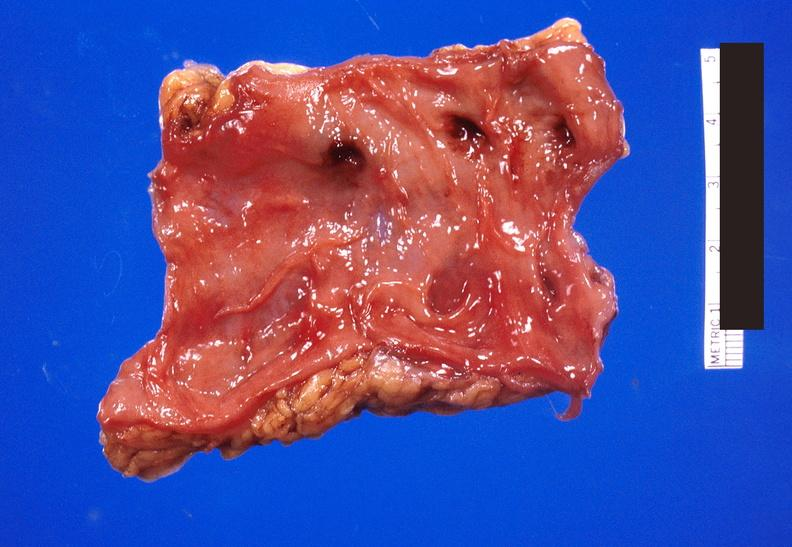what is present?
Answer the question using a single word or phrase. Gastrointestinal 